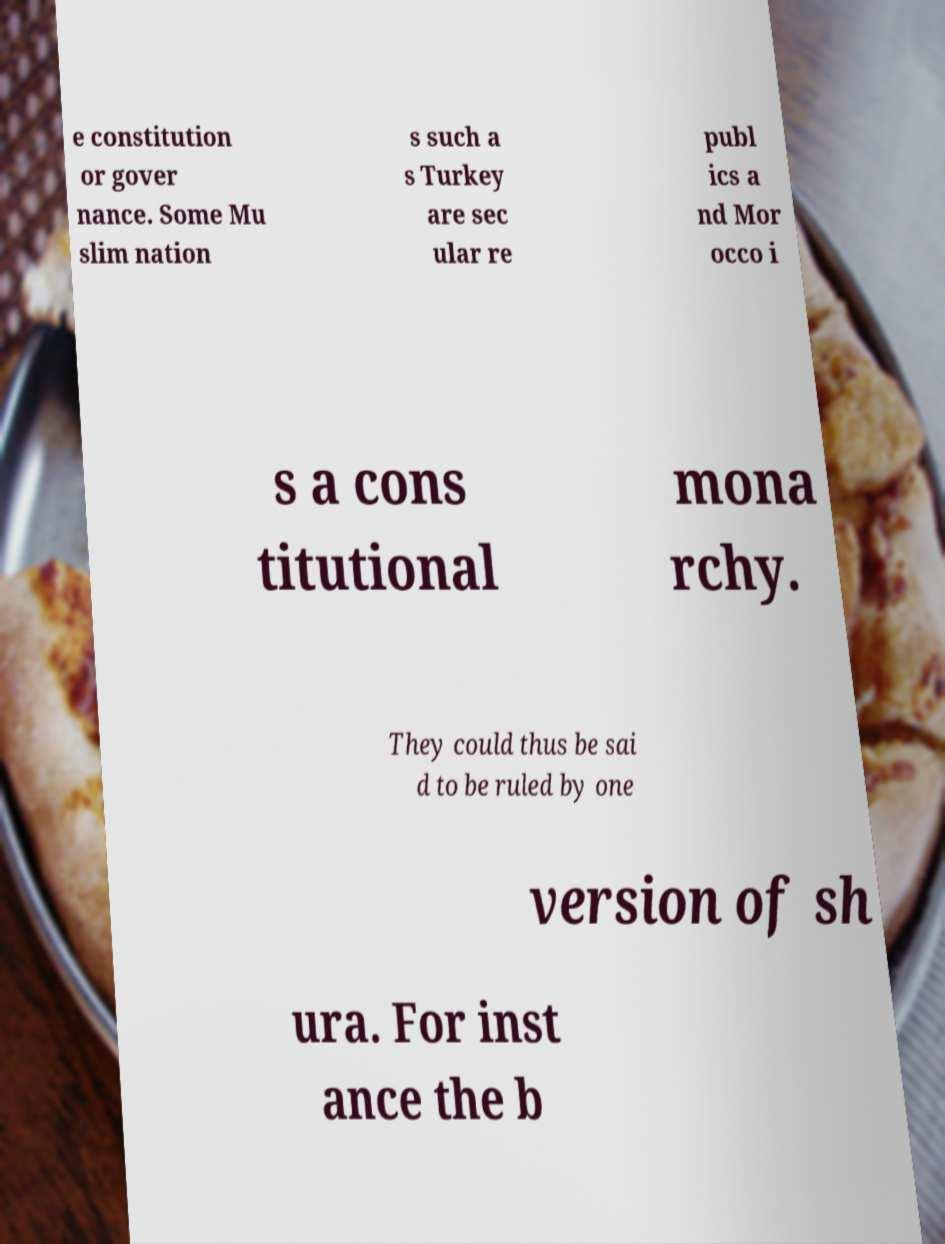I need the written content from this picture converted into text. Can you do that? e constitution or gover nance. Some Mu slim nation s such a s Turkey are sec ular re publ ics a nd Mor occo i s a cons titutional mona rchy. They could thus be sai d to be ruled by one version of sh ura. For inst ance the b 